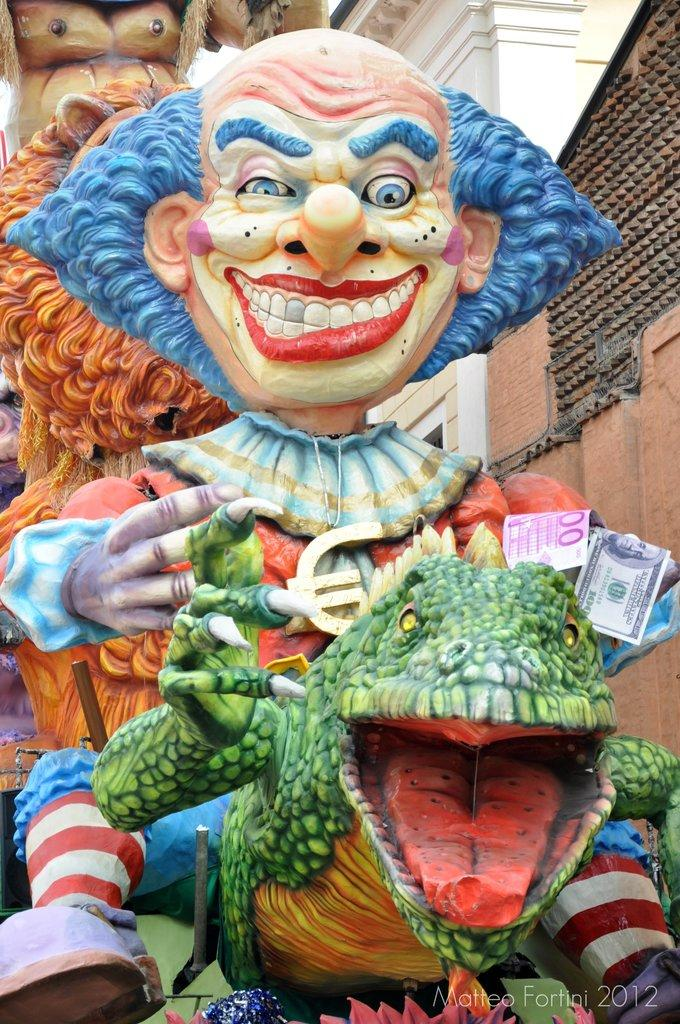What type of figures can be seen in the image? There are statues of monsters in the image. What else is present in the image besides the statues? There are buildings in the image. What type of crook can be seen in the image? There is no crook present in the image; it features statues of monsters and buildings. How many ladybugs are visible on the statues in the image? There are no ladybugs present on the statues in the image. 